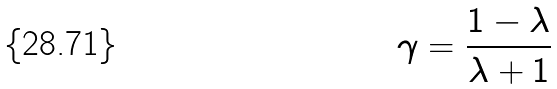<formula> <loc_0><loc_0><loc_500><loc_500>\gamma = \frac { 1 - \lambda } { \lambda + 1 }</formula> 